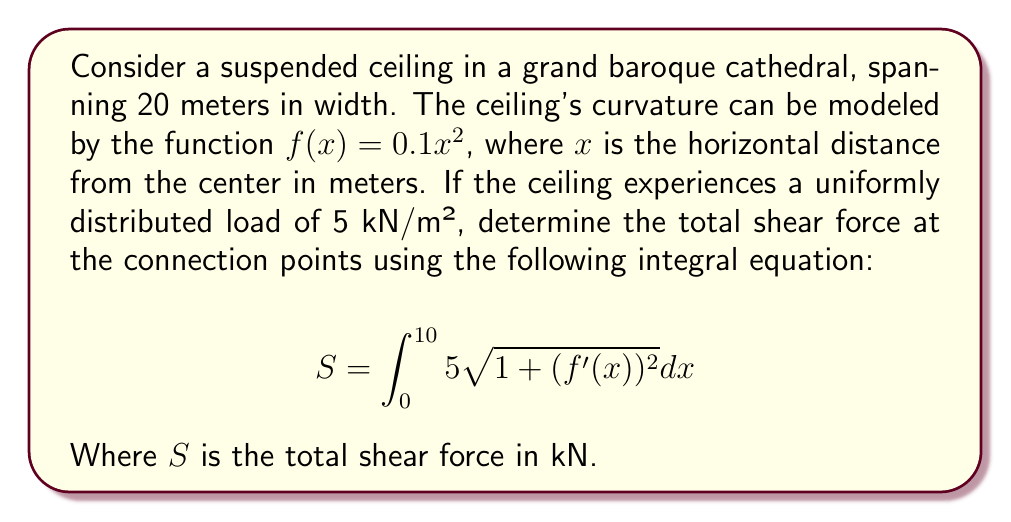Help me with this question. To solve this problem, we'll follow these steps:

1) First, we need to find $f'(x)$:
   $f(x) = 0.1x^2$
   $f'(x) = 0.2x$

2) Now, we can substitute this into our integral equation:
   $$S = \int_0^{10} 5\sqrt{1 + (0.2x)^2} dx$$

3) Simplify the expression under the square root:
   $$S = \int_0^{10} 5\sqrt{1 + 0.04x^2} dx$$

4) This integral doesn't have an elementary antiderivative, so we need to use a substitution:
   Let $u = 0.2x$, then $du = 0.2dx$ or $dx = 5du$
   When $x = 0$, $u = 0$
   When $x = 10$, $u = 2$

5) Rewrite the integral with this substitution:
   $$S = \int_0^2 25\sqrt{1 + u^2} du$$

6) This is a standard form integral. The antiderivative is:
   $$\frac{25}{2}(u\sqrt{1+u^2} + \ln(u + \sqrt{1+u^2}))$$

7) Evaluate this at the limits:
   $$S = \frac{25}{2}(2\sqrt{5} + \ln(2 + \sqrt{5})) - \frac{25}{2}(0 + \ln(0 + 1))$$

8) Simplify:
   $$S = \frac{25}{2}(2\sqrt{5} + \ln(2 + \sqrt{5}))$$

9) Calculate the numerical value:
   $S \approx 140.33$ kN
Answer: $140.33$ kN 